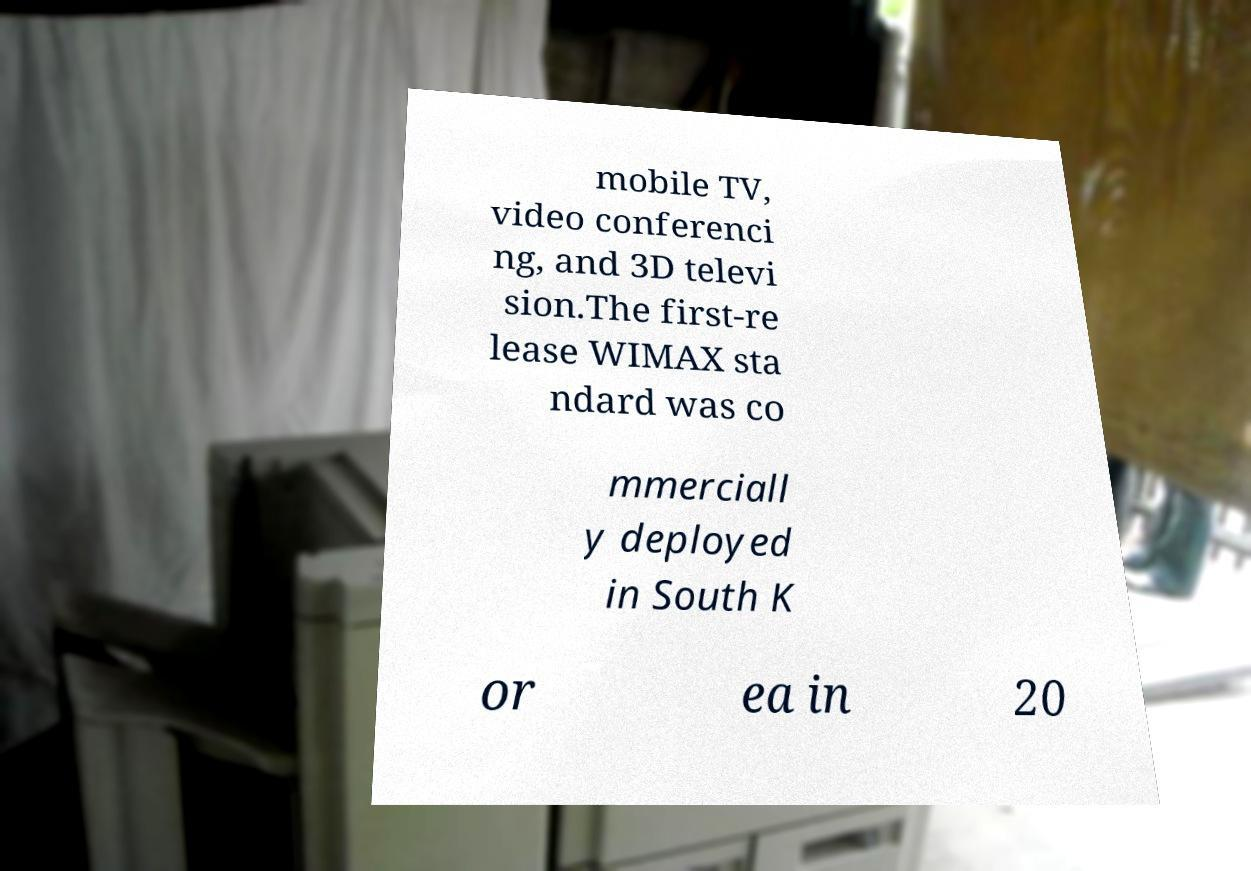Could you assist in decoding the text presented in this image and type it out clearly? mobile TV, video conferenci ng, and 3D televi sion.The first-re lease WIMAX sta ndard was co mmerciall y deployed in South K or ea in 20 